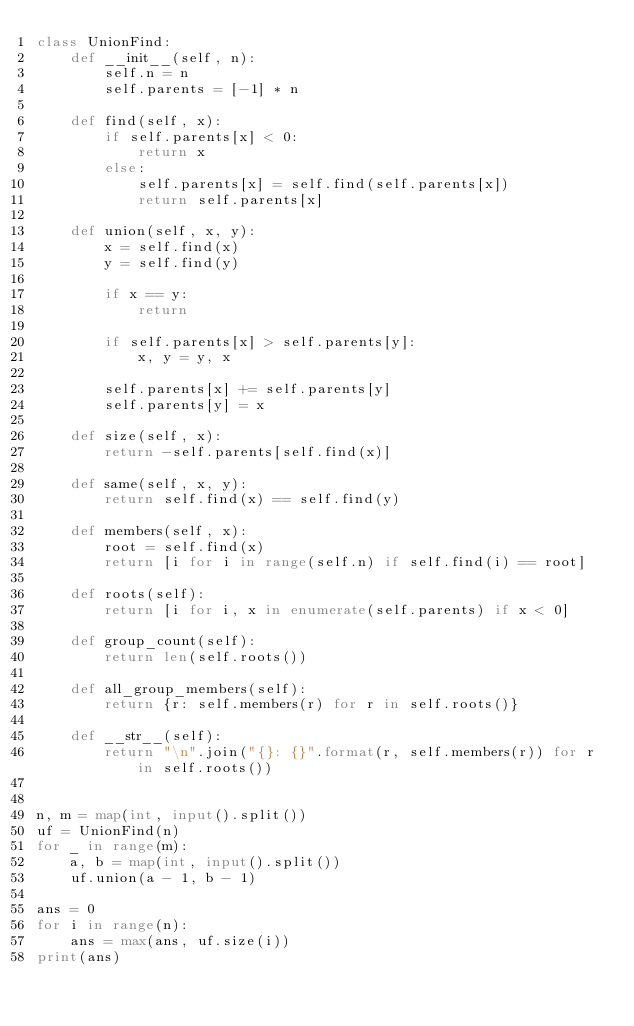Convert code to text. <code><loc_0><loc_0><loc_500><loc_500><_Python_>class UnionFind:
    def __init__(self, n):
        self.n = n
        self.parents = [-1] * n

    def find(self, x):
        if self.parents[x] < 0:
            return x
        else:
            self.parents[x] = self.find(self.parents[x])
            return self.parents[x]

    def union(self, x, y):
        x = self.find(x)
        y = self.find(y)

        if x == y:
            return

        if self.parents[x] > self.parents[y]:
            x, y = y, x

        self.parents[x] += self.parents[y]
        self.parents[y] = x

    def size(self, x):
        return -self.parents[self.find(x)]

    def same(self, x, y):
        return self.find(x) == self.find(y)

    def members(self, x):
        root = self.find(x)
        return [i for i in range(self.n) if self.find(i) == root]

    def roots(self):
        return [i for i, x in enumerate(self.parents) if x < 0]

    def group_count(self):
        return len(self.roots())

    def all_group_members(self):
        return {r: self.members(r) for r in self.roots()}

    def __str__(self):
        return "\n".join("{}: {}".format(r, self.members(r)) for r in self.roots())


n, m = map(int, input().split())
uf = UnionFind(n)
for _ in range(m):
    a, b = map(int, input().split())
    uf.union(a - 1, b - 1)

ans = 0
for i in range(n):
    ans = max(ans, uf.size(i))
print(ans)
</code> 